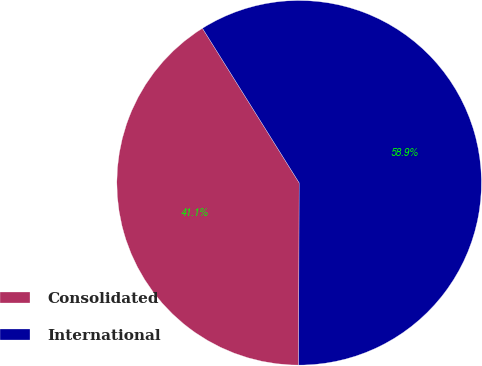Convert chart. <chart><loc_0><loc_0><loc_500><loc_500><pie_chart><fcel>Consolidated<fcel>International<nl><fcel>41.06%<fcel>58.94%<nl></chart> 